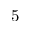Convert formula to latex. <formula><loc_0><loc_0><loc_500><loc_500>5</formula> 